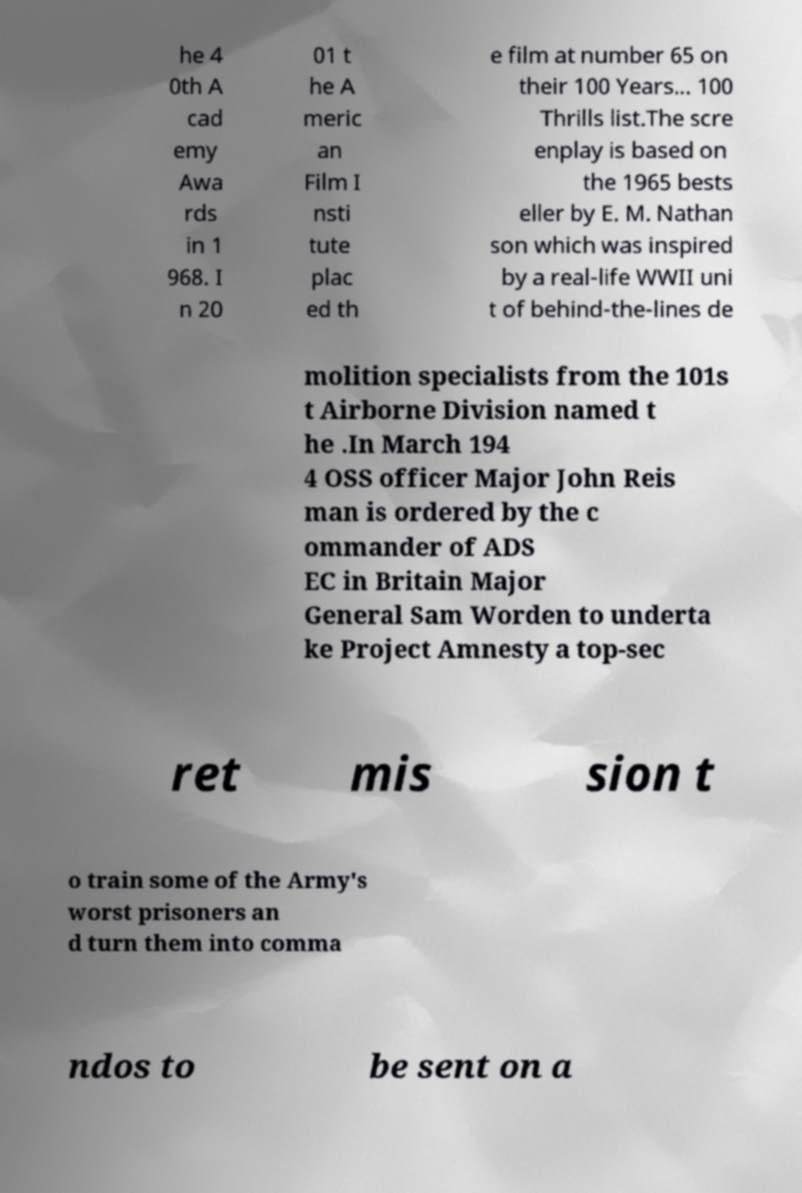Could you assist in decoding the text presented in this image and type it out clearly? he 4 0th A cad emy Awa rds in 1 968. I n 20 01 t he A meric an Film I nsti tute plac ed th e film at number 65 on their 100 Years... 100 Thrills list.The scre enplay is based on the 1965 bests eller by E. M. Nathan son which was inspired by a real-life WWII uni t of behind-the-lines de molition specialists from the 101s t Airborne Division named t he .In March 194 4 OSS officer Major John Reis man is ordered by the c ommander of ADS EC in Britain Major General Sam Worden to underta ke Project Amnesty a top-sec ret mis sion t o train some of the Army's worst prisoners an d turn them into comma ndos to be sent on a 